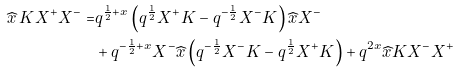<formula> <loc_0><loc_0><loc_500><loc_500>\widehat { x } \, K X ^ { + } X ^ { - } = & q ^ { \frac { 1 } { 2 } + x } \left ( q ^ { \frac { 1 } { 2 } } X ^ { + } K - q ^ { - \frac { 1 } { 2 } } X ^ { - } K \right ) \widehat { x } X ^ { - } \\ & + q ^ { - \frac { 1 } { 2 } + x } X ^ { - } \widehat { x } \left ( q ^ { - \frac { 1 } { 2 } } X ^ { - } K - q ^ { \frac { 1 } { 2 } } X ^ { + } K \right ) + q ^ { 2 x } \widehat { x } K X ^ { - } X ^ { + }</formula> 